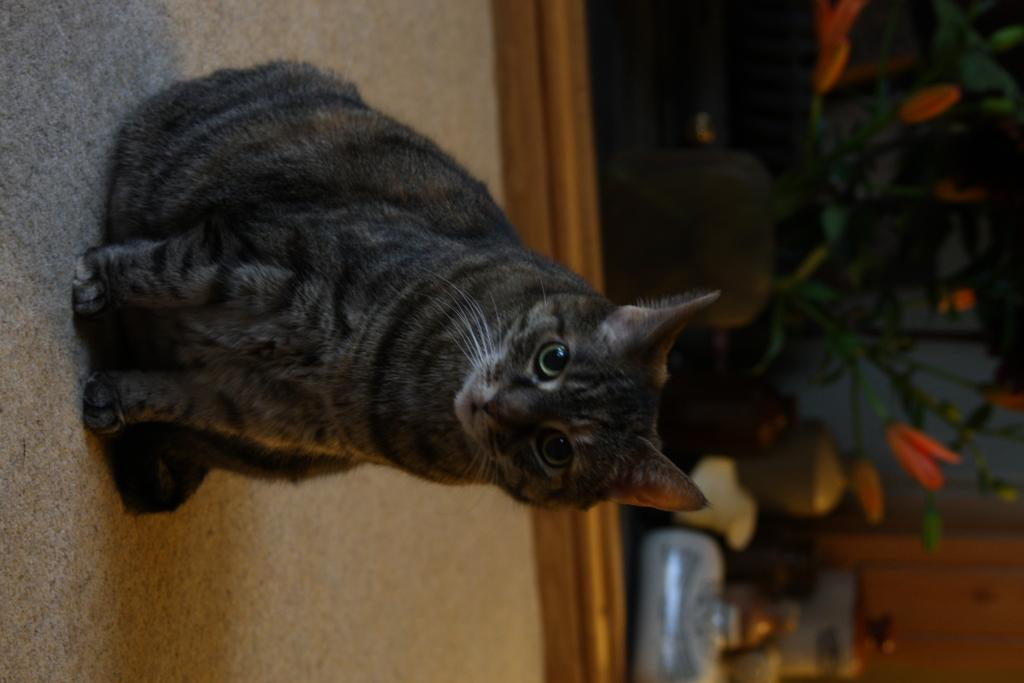What animal is present in the image? There is a cat in the image. Where is the cat located in the image? The cat is sitting on the floor. What can be seen in the background of the image? There is a plant pot and other objects in the background of the image. How is the background of the image depicted? The background of the image is blurred. Can you provide an example of a line in the image? There are no lines present in the image; it is a photograph of a cat sitting on the floor with a blurred background. 